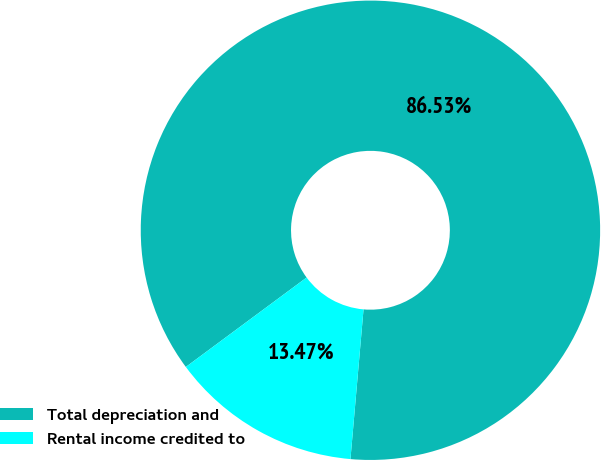<chart> <loc_0><loc_0><loc_500><loc_500><pie_chart><fcel>Total depreciation and<fcel>Rental income credited to<nl><fcel>86.53%<fcel>13.47%<nl></chart> 